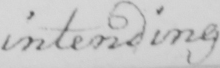Can you tell me what this handwritten text says? intending 